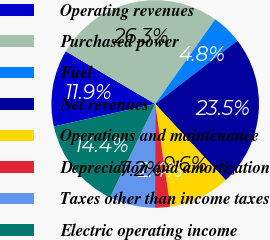Convert chart. <chart><loc_0><loc_0><loc_500><loc_500><pie_chart><fcel>Operating revenues<fcel>Purchased power<fcel>Fuel<fcel>Net revenues<fcel>Operations and maintenance<fcel>Depreciation and amortization<fcel>Taxes other than income taxes<fcel>Electric operating income<nl><fcel>11.95%<fcel>26.34%<fcel>4.75%<fcel>23.55%<fcel>9.55%<fcel>2.36%<fcel>7.15%<fcel>14.35%<nl></chart> 